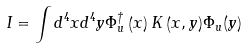<formula> <loc_0><loc_0><loc_500><loc_500>I = \int { d ^ { 4 } x d ^ { 4 } y \Phi _ { u } ^ { \dag } \left ( x \right ) K \left ( { x , y } \right ) } \Phi _ { u } ( y )</formula> 